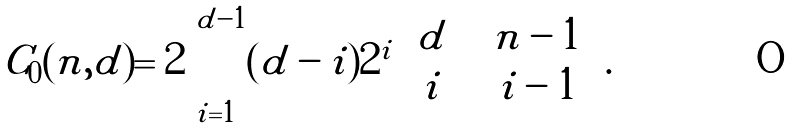Convert formula to latex. <formula><loc_0><loc_0><loc_500><loc_500>C _ { 0 } ( n , d ) = 2 \sum _ { i = 1 } ^ { d - 1 } ( d - i ) 2 ^ { i } \binom { d } { i } \binom { n - 1 } { i - 1 } .</formula> 